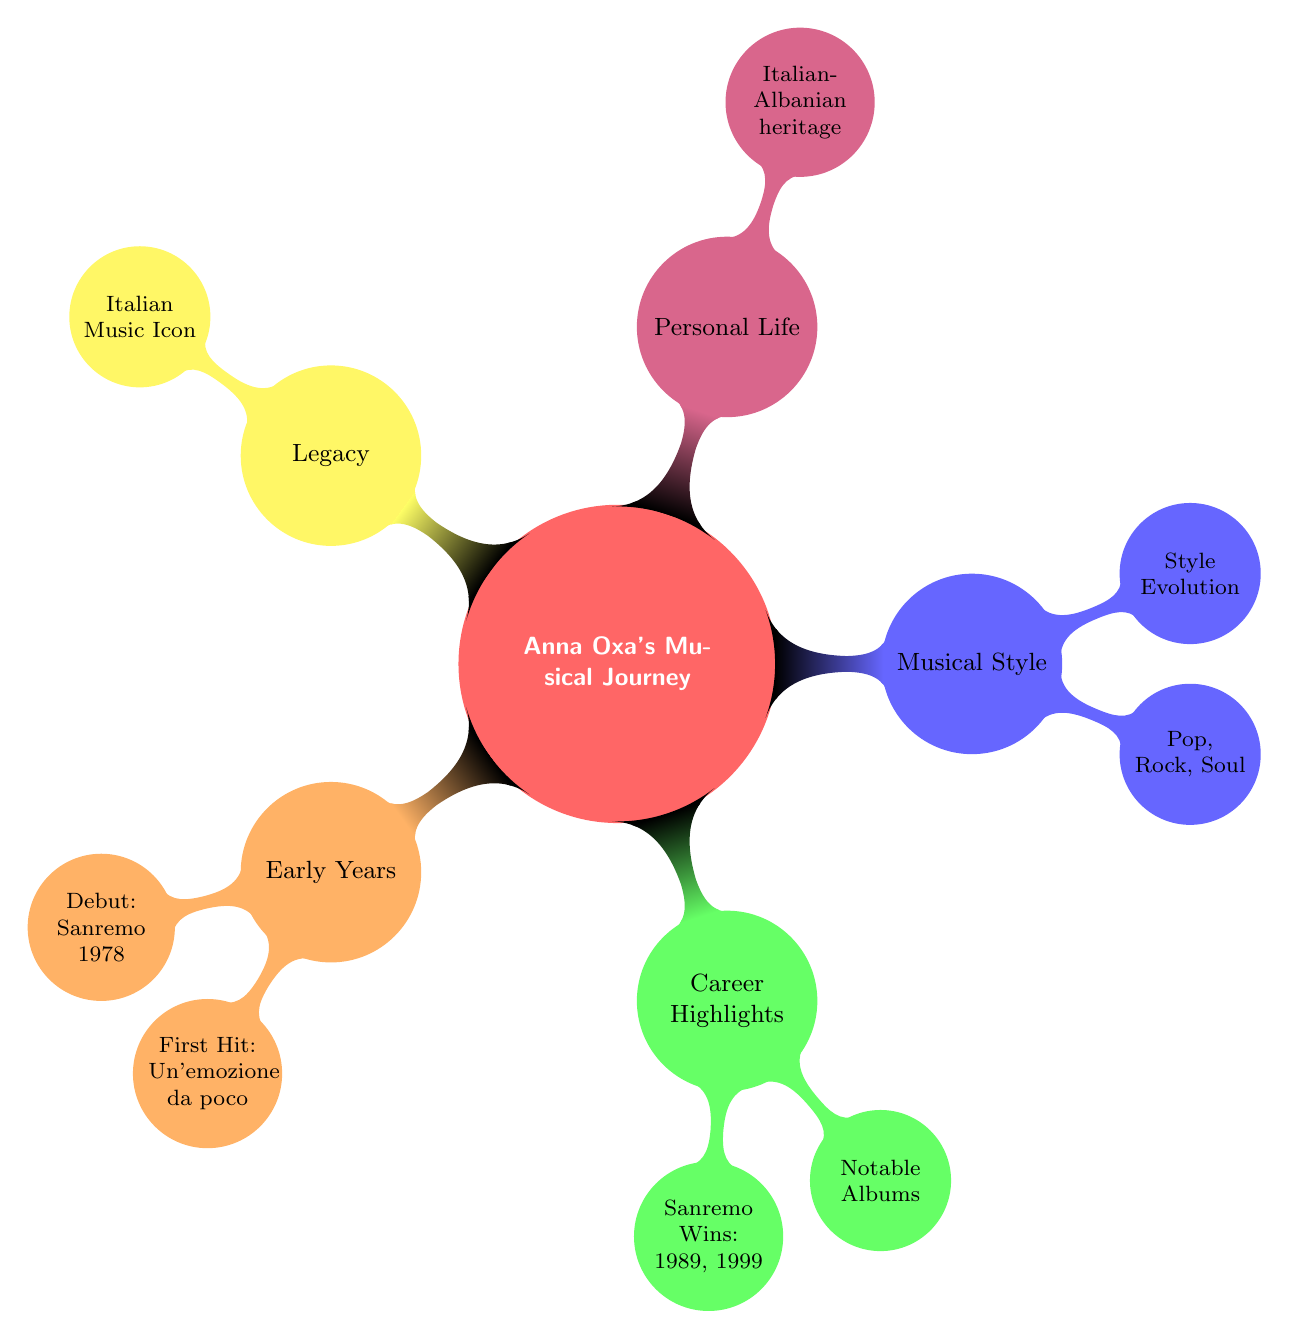What year did Anna Oxa debut at Sanremo? The diagram specifies that Anna Oxa appeared at the Sanremo Music Festival in 1978. Thus, by identifying the node for "Debut," we see it clearly states "Sanremo 1978."
Answer: 1978 How many Sanremo wins does Anna Oxa have listed? In the "Career Highlights" section, it shows that Anna Oxa has won Sanremo in two different years: 1989 and 1999. Therefore, counting these wins results in a total of two.
Answer: 2 What is Anna Oxa's first hit mentioned in the diagram? The node under "Early Years" lists her first hit as "Un'emozione da poco." This direct reference makes it clear.
Answer: Un'emozione da poco Which album did Anna Oxa collaborate on with Faust'O? The diagram states that Anna Oxa collaborated with Faust'O on the album titled "Oxa" in 1985. By reviewing the "Career Highlights" section that details collaborations, we confirm the album name.
Answer: Oxa What genres are associated with Anna Oxa's musical style? In the "Musical Style" section, three genres are specifically mentioned: Pop, Rock, and Soul. From this, we can list them.
Answer: Pop, Rock, Soul How did Anna Oxa's musical style evolve? The diagram indicates her musical style evolved "from Pop-Rock to more mature and eclectic sounds." This statement provides the necessary evolution context.
Answer: More mature and eclectic sounds What heritage does Anna Oxa have? The "Personal Life" node highlights her background as having Italian-Albanian heritage. This direct mention gives us the answer.
Answer: Italian-Albanian heritage What impact does Anna Oxa have on Italian music? The diagram indicates that Anna Oxa is recognized as an "Icon in Italian music," denoting her significant impact. This is a clear conclusion from the "Legacy" section.
Answer: Icon in Italian music 